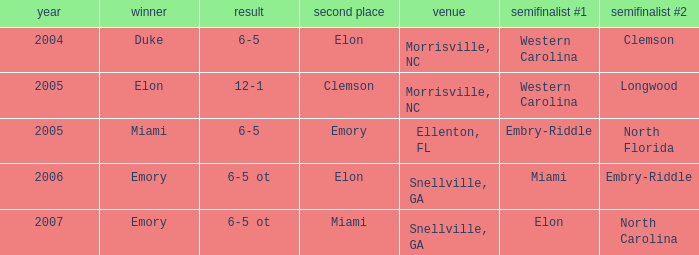Where was the final game played in 2007 Snellville, GA. 